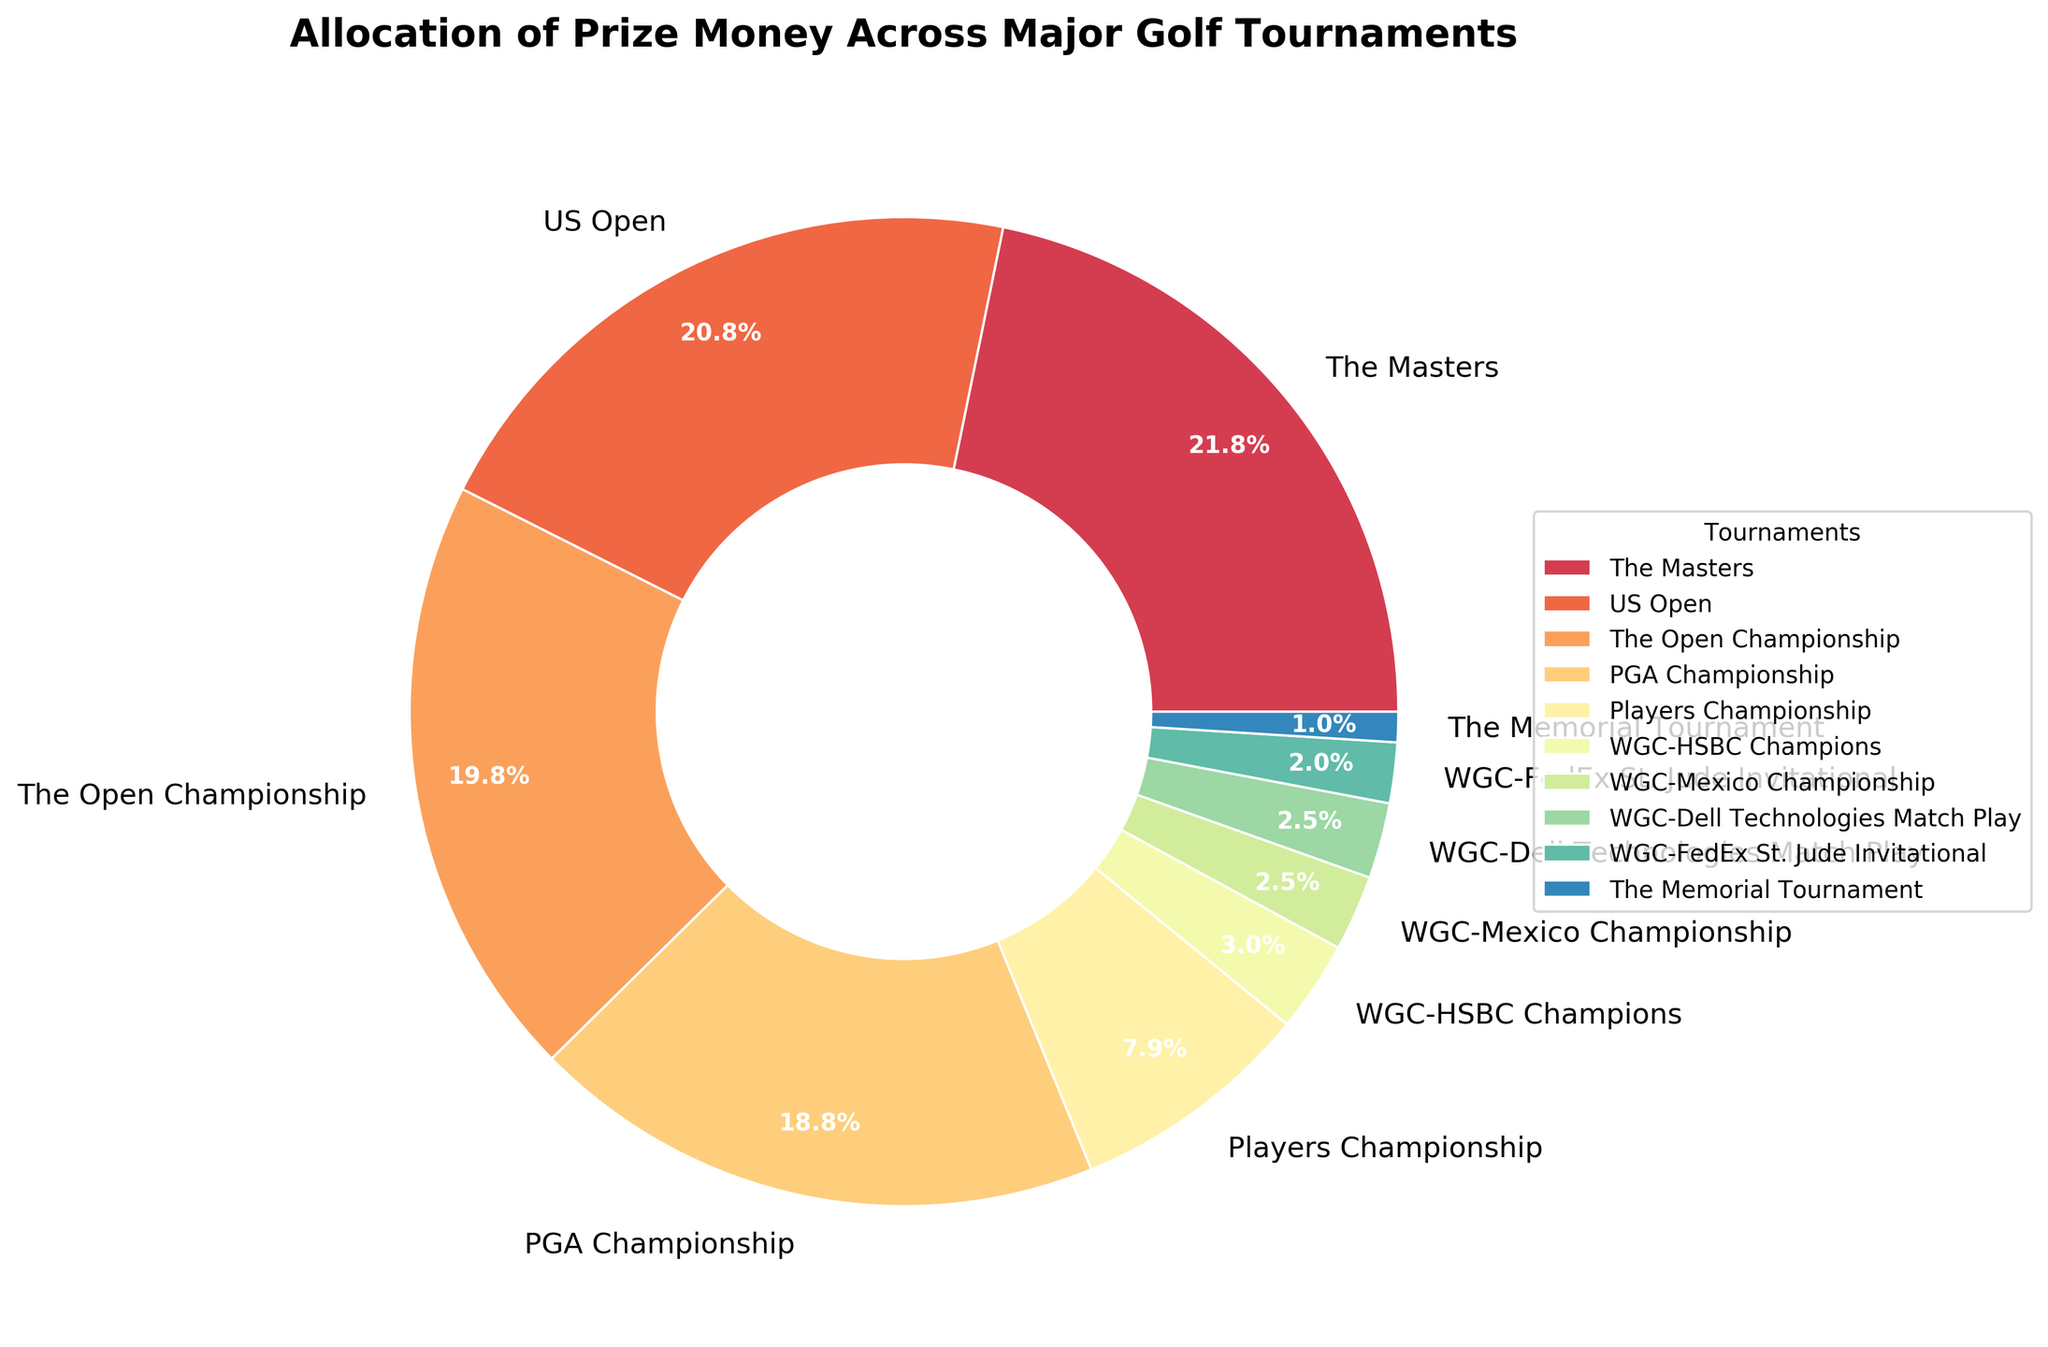Which tournament has the highest allocation of prize money? The pie chart shows that "The Masters" has the largest wedge, indicating the highest allocation of prize money.
Answer: The Masters What is the combined percentage of prize money allocation for The Masters and the US Open? The Masters has 22% and the US Open has 21%. Adding these together, 22% + 21% = 43%.
Answer: 43% Which tournament has the smallest allocation of prize money? The smallest wedge in the pie chart corresponds to "The Memorial Tournament," indicating it has the smallest allocation of prize money.
Answer: The Memorial Tournament How does the prize money allocation of the PGA Championship compare to the Players Championship? The PGA Championship allocation is 19% while the Players Championship is 8%. Therefore, the PGA Championship has a higher allocation.
Answer: PGA Championship has more What is the difference in prize money allocation between the Open Championship and the WGC-HSBC Champions? The Open Championship has 20% and the WGC-HSBC Champions have 3%. The difference is 20% - 3% = 17%.
Answer: 17% Which three tournaments have the smallest allocations, and what is their total percentage? The three smallest wedges are for "The Memorial Tournament" (1%), "WGC-FedEx St. Jude Invitational" (2%), and "WGC-Mexico Championship" (2.5%). Adding these, 1% + 2% + 2.5% = 5.5%.
Answer: The Memorial Tournament, WGC-FedEx St. Jude Invitational, WGC-Mexico Championship; 5.5% What is the average prize money allocation for the four WGC tournaments combined? The four WGC tournaments have allocations of 3%, 2.5%, 2.5%, and 2%. Adding these gives 3% + 2.5% + 2.5% + 2% = 10%. Dividing by 4, the average is 10% / 4 = 2.5%.
Answer: 2.5% Which tournaments have a larger allocation than the average allocation of all tournaments? First calculate the average allocation. The total prize allocation is 100%, divided by 10 tournaments, gives an average of 10%. The tournaments with allocations higher than 10% are The Masters (22%), US Open (21%), Open Championship (20%), and PGA Championship (19%).
Answer: The Masters, US Open, Open Championship, PGA Championship What is the combined prize money allocation for the three tournaments with allocations closest to 20%? The tournaments close to 20% are The Masters (22%), US Open (21%), and Open Championship (20%). Their combined allocation is 22% + 21% + 20% = 63%.
Answer: 63% Which two tournaments have equal allocations and what are their values? The WGC-Mexico Championship and WGC-Dell Technologies Match Play both have allocations of 2.5%, as indicated by the identical sizes of their wedges.
Answer: WGC-Mexico Championship and WGC-Dell Technologies Match Play; 2.5% each 